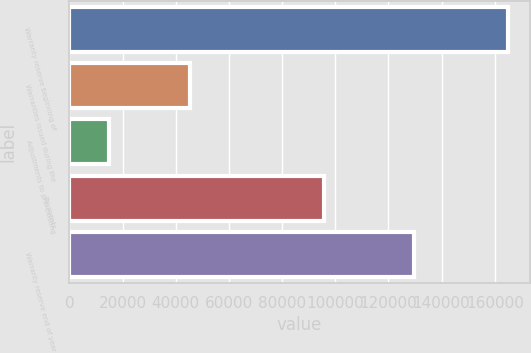Convert chart to OTSL. <chart><loc_0><loc_0><loc_500><loc_500><bar_chart><fcel>Warranty reserve beginning of<fcel>Warranties issued during the<fcel>Adjustments to pre-existing<fcel>Payments<fcel>Warranty reserve end of year<nl><fcel>164841<fcel>45338<fcel>15042<fcel>95772<fcel>129449<nl></chart> 